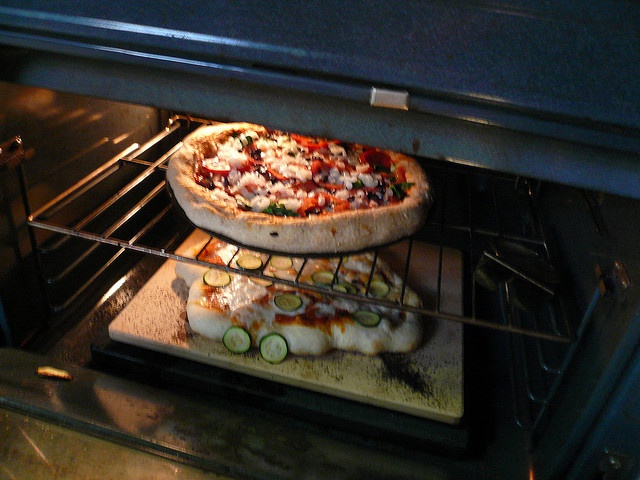Describe the objects in this image and their specific colors. I can see oven in black, navy, olive, and maroon tones, pizza in black, gray, maroon, and tan tones, and pizza in black, gray, olive, and maroon tones in this image. 